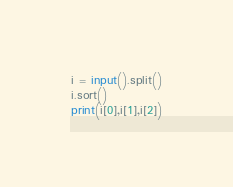<code> <loc_0><loc_0><loc_500><loc_500><_Python_>i = input().split()
i.sort()
print(i[0],i[1],i[2])
</code> 